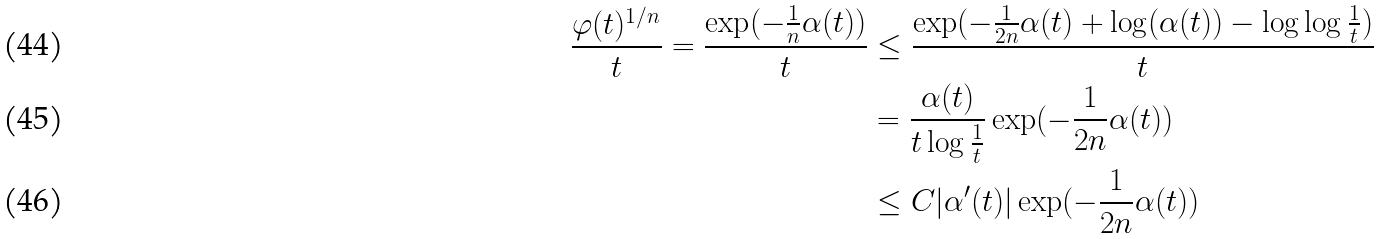Convert formula to latex. <formula><loc_0><loc_0><loc_500><loc_500>\frac { \varphi ( t ) ^ { 1 / n } } { t } = \frac { \exp ( - \frac { 1 } { n } \alpha ( t ) ) } { t } & \leq \frac { \exp ( - \frac { 1 } { 2 n } \alpha ( t ) + \log ( \alpha ( t ) ) - \log \log \frac { 1 } { t } ) } { t } \\ & = \frac { \alpha ( t ) } { t \log \frac { 1 } { t } } \exp ( - \frac { 1 } { 2 n } \alpha ( t ) ) \\ & \leq C | \alpha ^ { \prime } ( t ) | \exp ( - \frac { 1 } { 2 n } \alpha ( t ) )</formula> 